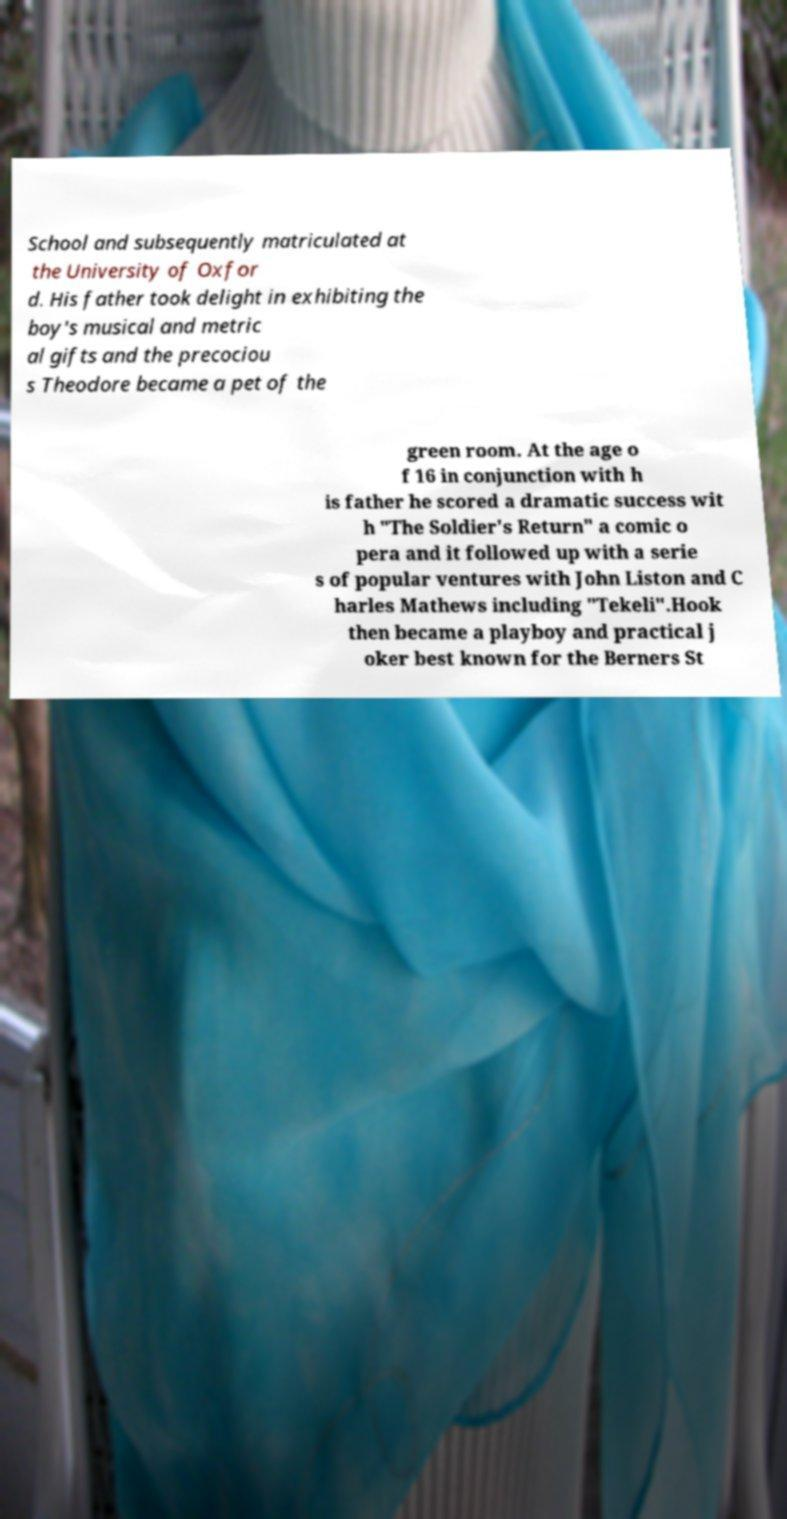For documentation purposes, I need the text within this image transcribed. Could you provide that? School and subsequently matriculated at the University of Oxfor d. His father took delight in exhibiting the boy's musical and metric al gifts and the precociou s Theodore became a pet of the green room. At the age o f 16 in conjunction with h is father he scored a dramatic success wit h "The Soldier's Return" a comic o pera and it followed up with a serie s of popular ventures with John Liston and C harles Mathews including "Tekeli".Hook then became a playboy and practical j oker best known for the Berners St 